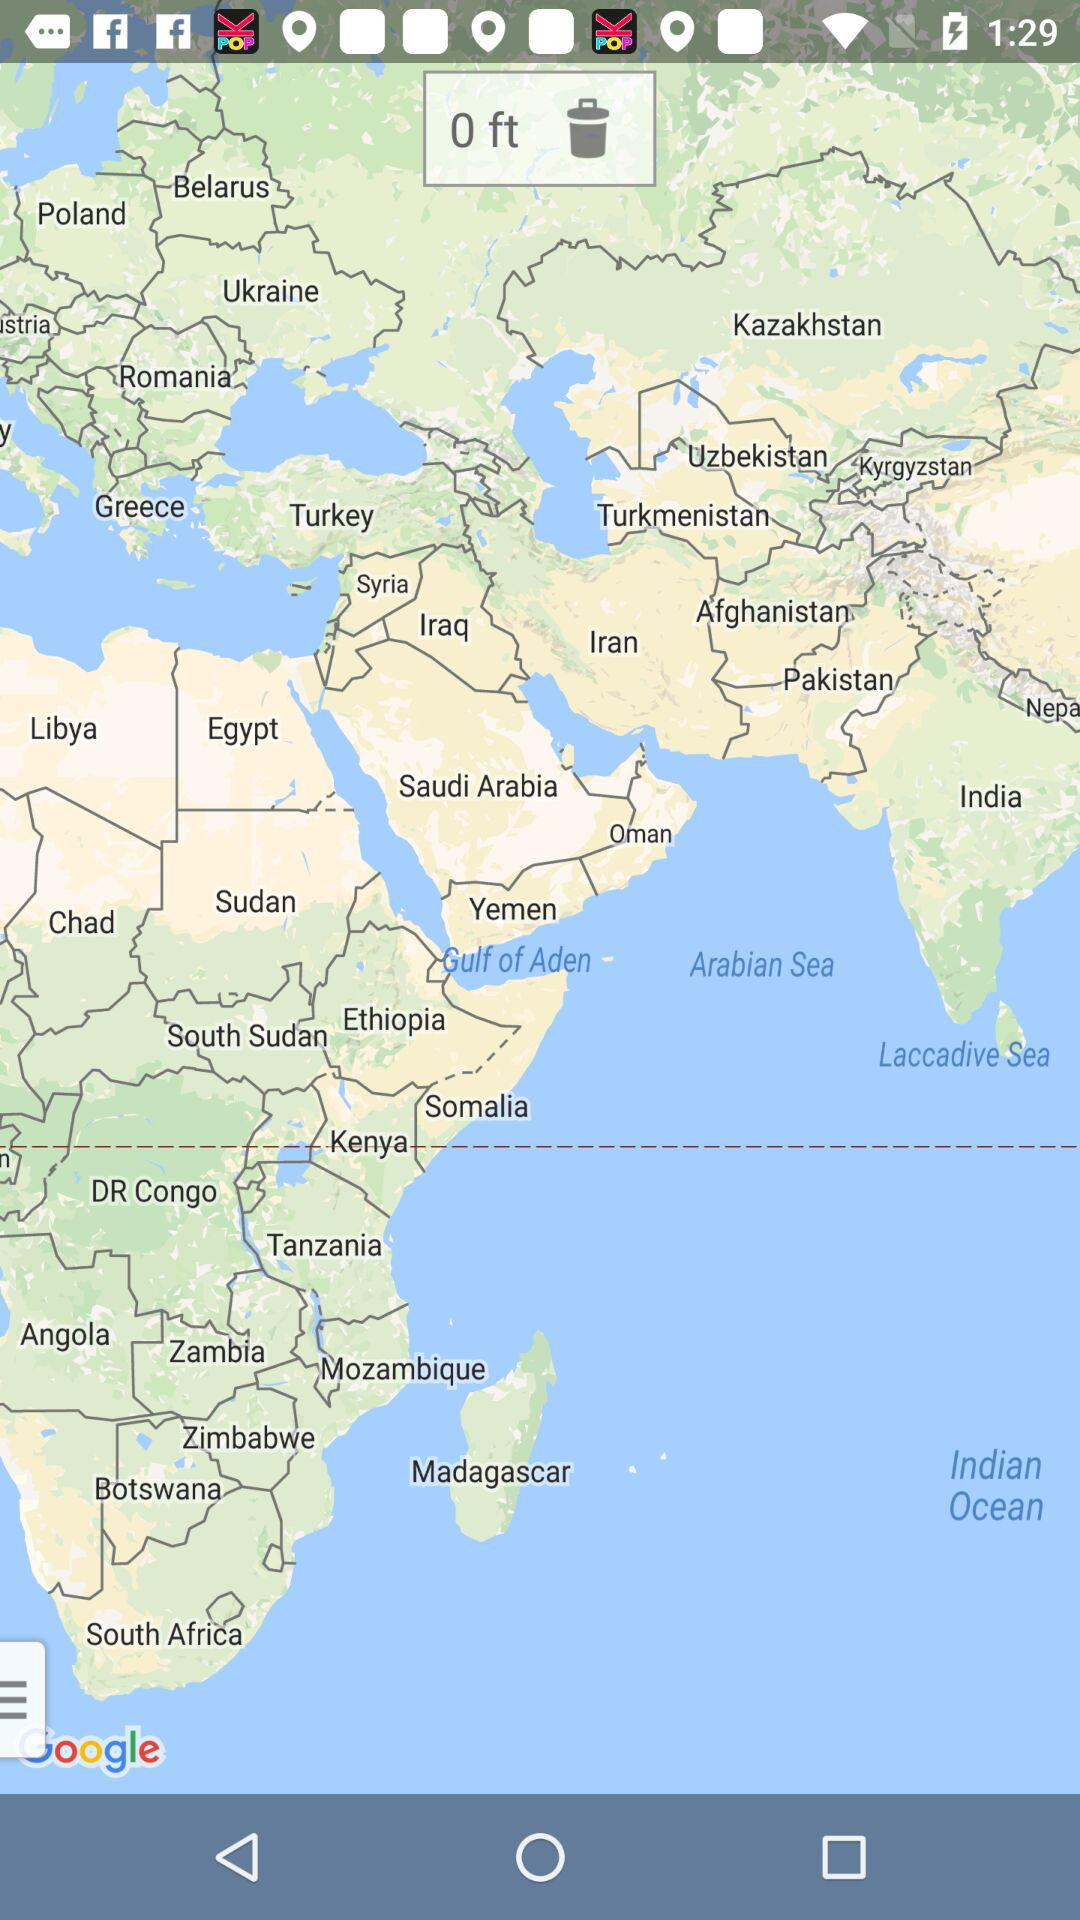What is the value in feet? The value in feet is 0. 